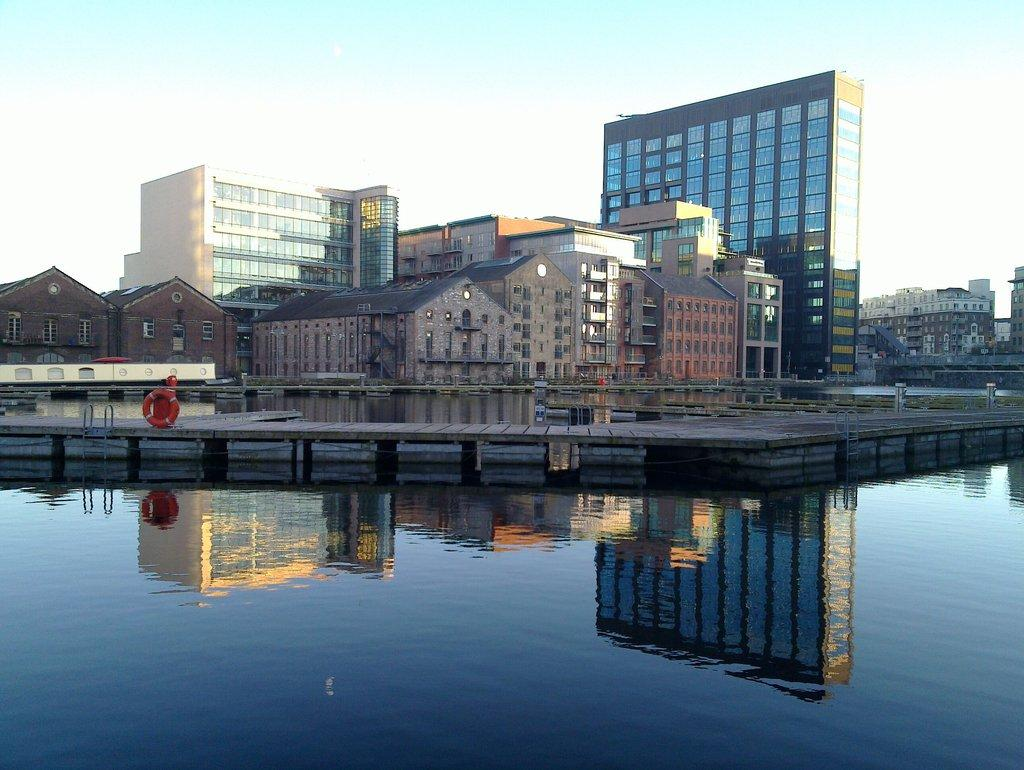What is the primary element visible in the image? There is water in the image. What objects are associated with the water in the image? There are swimming pool ladders and a safety ring in the image. What type of structures can be seen in the image? There are buildings in the image. What can be seen in the background of the image? The sky is visible in the background of the image. How many chickens are sitting on the cushion in the image? There are no chickens or cushions present in the image. 